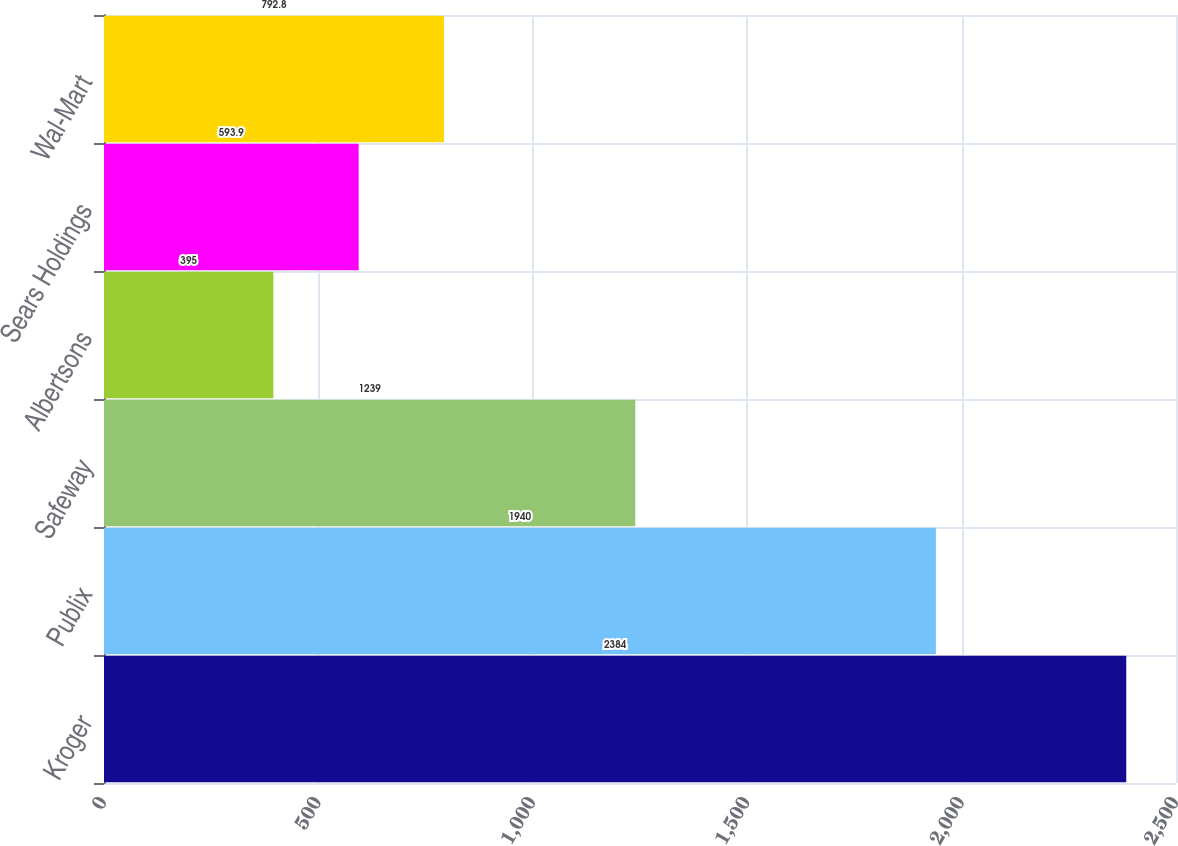<chart> <loc_0><loc_0><loc_500><loc_500><bar_chart><fcel>Kroger<fcel>Publix<fcel>Safeway<fcel>Albertsons<fcel>Sears Holdings<fcel>Wal-Mart<nl><fcel>2384<fcel>1940<fcel>1239<fcel>395<fcel>593.9<fcel>792.8<nl></chart> 